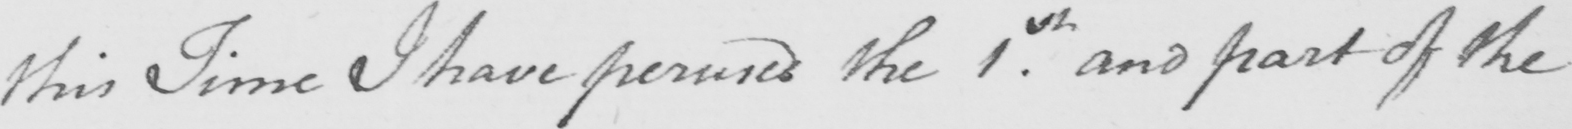Can you read and transcribe this handwriting? this Time I have perused the 1.st and part of the 